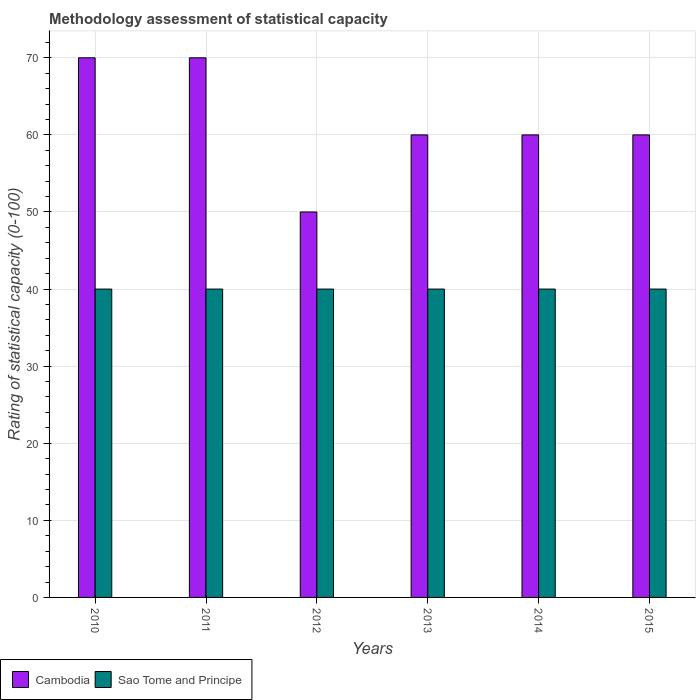Are the number of bars per tick equal to the number of legend labels?
Your response must be concise. Yes. Are the number of bars on each tick of the X-axis equal?
Offer a very short reply. Yes. What is the label of the 2nd group of bars from the left?
Offer a very short reply. 2011. Across all years, what is the maximum rating of statistical capacity in Cambodia?
Your answer should be very brief. 70. Across all years, what is the minimum rating of statistical capacity in Cambodia?
Provide a short and direct response. 50. In which year was the rating of statistical capacity in Sao Tome and Principe maximum?
Provide a succinct answer. 2010. What is the total rating of statistical capacity in Cambodia in the graph?
Offer a terse response. 370. What is the difference between the rating of statistical capacity in Cambodia in 2011 and that in 2015?
Your answer should be very brief. 10. What is the difference between the rating of statistical capacity in Sao Tome and Principe in 2015 and the rating of statistical capacity in Cambodia in 2012?
Make the answer very short. -10. In how many years, is the rating of statistical capacity in Sao Tome and Principe greater than 56?
Your answer should be compact. 0. What is the ratio of the rating of statistical capacity in Cambodia in 2013 to that in 2015?
Provide a succinct answer. 1. Is the rating of statistical capacity in Cambodia in 2010 less than that in 2015?
Provide a short and direct response. No. What is the difference between the highest and the second highest rating of statistical capacity in Cambodia?
Make the answer very short. 0. What is the difference between the highest and the lowest rating of statistical capacity in Sao Tome and Principe?
Your answer should be compact. 0. In how many years, is the rating of statistical capacity in Sao Tome and Principe greater than the average rating of statistical capacity in Sao Tome and Principe taken over all years?
Provide a short and direct response. 0. Is the sum of the rating of statistical capacity in Sao Tome and Principe in 2010 and 2012 greater than the maximum rating of statistical capacity in Cambodia across all years?
Ensure brevity in your answer.  Yes. What does the 2nd bar from the left in 2011 represents?
Offer a very short reply. Sao Tome and Principe. What does the 1st bar from the right in 2012 represents?
Offer a terse response. Sao Tome and Principe. How many bars are there?
Your answer should be compact. 12. How many years are there in the graph?
Your response must be concise. 6. What is the difference between two consecutive major ticks on the Y-axis?
Give a very brief answer. 10. Are the values on the major ticks of Y-axis written in scientific E-notation?
Provide a succinct answer. No. Does the graph contain any zero values?
Provide a succinct answer. No. Where does the legend appear in the graph?
Offer a very short reply. Bottom left. How many legend labels are there?
Provide a succinct answer. 2. How are the legend labels stacked?
Offer a very short reply. Horizontal. What is the title of the graph?
Your answer should be very brief. Methodology assessment of statistical capacity. Does "Kenya" appear as one of the legend labels in the graph?
Your answer should be compact. No. What is the label or title of the X-axis?
Provide a succinct answer. Years. What is the label or title of the Y-axis?
Your answer should be very brief. Rating of statistical capacity (0-100). What is the Rating of statistical capacity (0-100) of Sao Tome and Principe in 2010?
Offer a very short reply. 40. What is the Rating of statistical capacity (0-100) in Cambodia in 2011?
Give a very brief answer. 70. What is the Rating of statistical capacity (0-100) in Sao Tome and Principe in 2011?
Keep it short and to the point. 40. What is the Rating of statistical capacity (0-100) of Cambodia in 2012?
Give a very brief answer. 50. What is the Rating of statistical capacity (0-100) in Sao Tome and Principe in 2012?
Your answer should be very brief. 40. What is the Rating of statistical capacity (0-100) of Cambodia in 2013?
Ensure brevity in your answer.  60. What is the Rating of statistical capacity (0-100) of Sao Tome and Principe in 2013?
Give a very brief answer. 40. What is the Rating of statistical capacity (0-100) in Cambodia in 2014?
Keep it short and to the point. 60. Across all years, what is the maximum Rating of statistical capacity (0-100) in Sao Tome and Principe?
Your answer should be very brief. 40. Across all years, what is the minimum Rating of statistical capacity (0-100) of Cambodia?
Keep it short and to the point. 50. Across all years, what is the minimum Rating of statistical capacity (0-100) of Sao Tome and Principe?
Your answer should be compact. 40. What is the total Rating of statistical capacity (0-100) in Cambodia in the graph?
Keep it short and to the point. 370. What is the total Rating of statistical capacity (0-100) in Sao Tome and Principe in the graph?
Your answer should be very brief. 240. What is the difference between the Rating of statistical capacity (0-100) of Cambodia in 2010 and that in 2011?
Offer a very short reply. 0. What is the difference between the Rating of statistical capacity (0-100) in Sao Tome and Principe in 2010 and that in 2012?
Your response must be concise. 0. What is the difference between the Rating of statistical capacity (0-100) in Cambodia in 2010 and that in 2013?
Your answer should be very brief. 10. What is the difference between the Rating of statistical capacity (0-100) of Sao Tome and Principe in 2010 and that in 2013?
Offer a terse response. 0. What is the difference between the Rating of statistical capacity (0-100) of Sao Tome and Principe in 2010 and that in 2014?
Offer a terse response. 0. What is the difference between the Rating of statistical capacity (0-100) of Cambodia in 2010 and that in 2015?
Provide a succinct answer. 10. What is the difference between the Rating of statistical capacity (0-100) of Sao Tome and Principe in 2011 and that in 2012?
Your answer should be very brief. 0. What is the difference between the Rating of statistical capacity (0-100) in Sao Tome and Principe in 2011 and that in 2013?
Make the answer very short. 0. What is the difference between the Rating of statistical capacity (0-100) of Cambodia in 2011 and that in 2014?
Keep it short and to the point. 10. What is the difference between the Rating of statistical capacity (0-100) in Sao Tome and Principe in 2011 and that in 2014?
Offer a very short reply. 0. What is the difference between the Rating of statistical capacity (0-100) in Sao Tome and Principe in 2011 and that in 2015?
Offer a terse response. 0. What is the difference between the Rating of statistical capacity (0-100) in Sao Tome and Principe in 2012 and that in 2013?
Ensure brevity in your answer.  0. What is the difference between the Rating of statistical capacity (0-100) in Cambodia in 2012 and that in 2014?
Provide a short and direct response. -10. What is the difference between the Rating of statistical capacity (0-100) in Sao Tome and Principe in 2012 and that in 2014?
Offer a very short reply. 0. What is the difference between the Rating of statistical capacity (0-100) in Cambodia in 2012 and that in 2015?
Provide a short and direct response. -10. What is the difference between the Rating of statistical capacity (0-100) in Sao Tome and Principe in 2012 and that in 2015?
Provide a succinct answer. 0. What is the difference between the Rating of statistical capacity (0-100) of Cambodia in 2013 and that in 2014?
Your answer should be compact. 0. What is the difference between the Rating of statistical capacity (0-100) of Sao Tome and Principe in 2013 and that in 2015?
Make the answer very short. 0. What is the difference between the Rating of statistical capacity (0-100) in Cambodia in 2010 and the Rating of statistical capacity (0-100) in Sao Tome and Principe in 2011?
Your answer should be compact. 30. What is the difference between the Rating of statistical capacity (0-100) of Cambodia in 2010 and the Rating of statistical capacity (0-100) of Sao Tome and Principe in 2012?
Your answer should be very brief. 30. What is the difference between the Rating of statistical capacity (0-100) in Cambodia in 2010 and the Rating of statistical capacity (0-100) in Sao Tome and Principe in 2013?
Provide a short and direct response. 30. What is the difference between the Rating of statistical capacity (0-100) in Cambodia in 2010 and the Rating of statistical capacity (0-100) in Sao Tome and Principe in 2015?
Your answer should be compact. 30. What is the difference between the Rating of statistical capacity (0-100) in Cambodia in 2011 and the Rating of statistical capacity (0-100) in Sao Tome and Principe in 2013?
Your response must be concise. 30. What is the difference between the Rating of statistical capacity (0-100) in Cambodia in 2012 and the Rating of statistical capacity (0-100) in Sao Tome and Principe in 2015?
Make the answer very short. 10. What is the difference between the Rating of statistical capacity (0-100) of Cambodia in 2013 and the Rating of statistical capacity (0-100) of Sao Tome and Principe in 2014?
Provide a short and direct response. 20. What is the difference between the Rating of statistical capacity (0-100) of Cambodia in 2013 and the Rating of statistical capacity (0-100) of Sao Tome and Principe in 2015?
Your answer should be very brief. 20. What is the difference between the Rating of statistical capacity (0-100) in Cambodia in 2014 and the Rating of statistical capacity (0-100) in Sao Tome and Principe in 2015?
Make the answer very short. 20. What is the average Rating of statistical capacity (0-100) in Cambodia per year?
Provide a succinct answer. 61.67. In the year 2011, what is the difference between the Rating of statistical capacity (0-100) in Cambodia and Rating of statistical capacity (0-100) in Sao Tome and Principe?
Ensure brevity in your answer.  30. In the year 2013, what is the difference between the Rating of statistical capacity (0-100) in Cambodia and Rating of statistical capacity (0-100) in Sao Tome and Principe?
Ensure brevity in your answer.  20. In the year 2014, what is the difference between the Rating of statistical capacity (0-100) of Cambodia and Rating of statistical capacity (0-100) of Sao Tome and Principe?
Provide a short and direct response. 20. What is the ratio of the Rating of statistical capacity (0-100) of Sao Tome and Principe in 2010 to that in 2011?
Your answer should be compact. 1. What is the ratio of the Rating of statistical capacity (0-100) in Cambodia in 2010 to that in 2012?
Ensure brevity in your answer.  1.4. What is the ratio of the Rating of statistical capacity (0-100) in Sao Tome and Principe in 2010 to that in 2012?
Provide a short and direct response. 1. What is the ratio of the Rating of statistical capacity (0-100) of Cambodia in 2010 to that in 2013?
Your answer should be compact. 1.17. What is the ratio of the Rating of statistical capacity (0-100) of Cambodia in 2010 to that in 2015?
Offer a terse response. 1.17. What is the ratio of the Rating of statistical capacity (0-100) in Sao Tome and Principe in 2010 to that in 2015?
Your answer should be compact. 1. What is the ratio of the Rating of statistical capacity (0-100) in Cambodia in 2011 to that in 2012?
Your answer should be compact. 1.4. What is the ratio of the Rating of statistical capacity (0-100) in Cambodia in 2011 to that in 2014?
Give a very brief answer. 1.17. What is the ratio of the Rating of statistical capacity (0-100) of Sao Tome and Principe in 2011 to that in 2014?
Offer a very short reply. 1. What is the ratio of the Rating of statistical capacity (0-100) of Cambodia in 2011 to that in 2015?
Your answer should be very brief. 1.17. What is the ratio of the Rating of statistical capacity (0-100) in Sao Tome and Principe in 2011 to that in 2015?
Offer a terse response. 1. What is the ratio of the Rating of statistical capacity (0-100) of Sao Tome and Principe in 2012 to that in 2013?
Your answer should be very brief. 1. What is the ratio of the Rating of statistical capacity (0-100) in Sao Tome and Principe in 2012 to that in 2015?
Offer a very short reply. 1. What is the ratio of the Rating of statistical capacity (0-100) in Cambodia in 2013 to that in 2014?
Provide a succinct answer. 1. What is the ratio of the Rating of statistical capacity (0-100) in Sao Tome and Principe in 2013 to that in 2014?
Your answer should be compact. 1. What is the ratio of the Rating of statistical capacity (0-100) in Cambodia in 2013 to that in 2015?
Offer a very short reply. 1. What is the ratio of the Rating of statistical capacity (0-100) of Sao Tome and Principe in 2013 to that in 2015?
Provide a succinct answer. 1. What is the difference between the highest and the second highest Rating of statistical capacity (0-100) in Sao Tome and Principe?
Make the answer very short. 0. What is the difference between the highest and the lowest Rating of statistical capacity (0-100) in Sao Tome and Principe?
Your answer should be very brief. 0. 